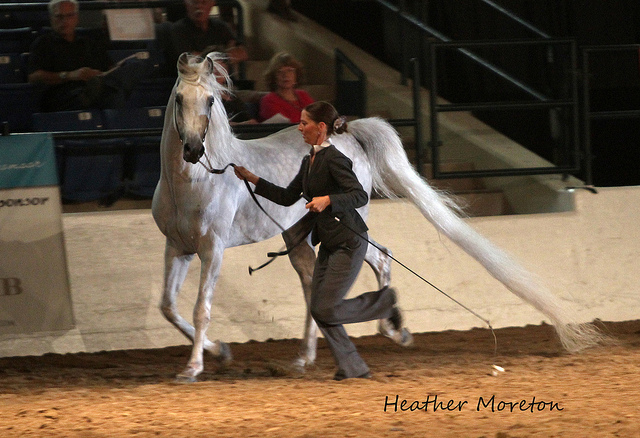Identify the text displayed in this image. Heather Moreton B 